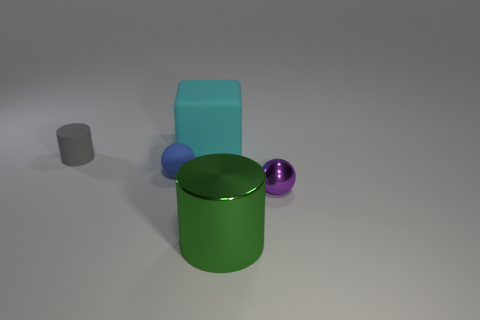Add 3 tiny cyan objects. How many objects exist? 8 Subtract all balls. How many objects are left? 3 Add 4 big green objects. How many big green objects are left? 5 Add 4 gray cylinders. How many gray cylinders exist? 5 Subtract 0 purple cylinders. How many objects are left? 5 Subtract all red matte spheres. Subtract all small purple spheres. How many objects are left? 4 